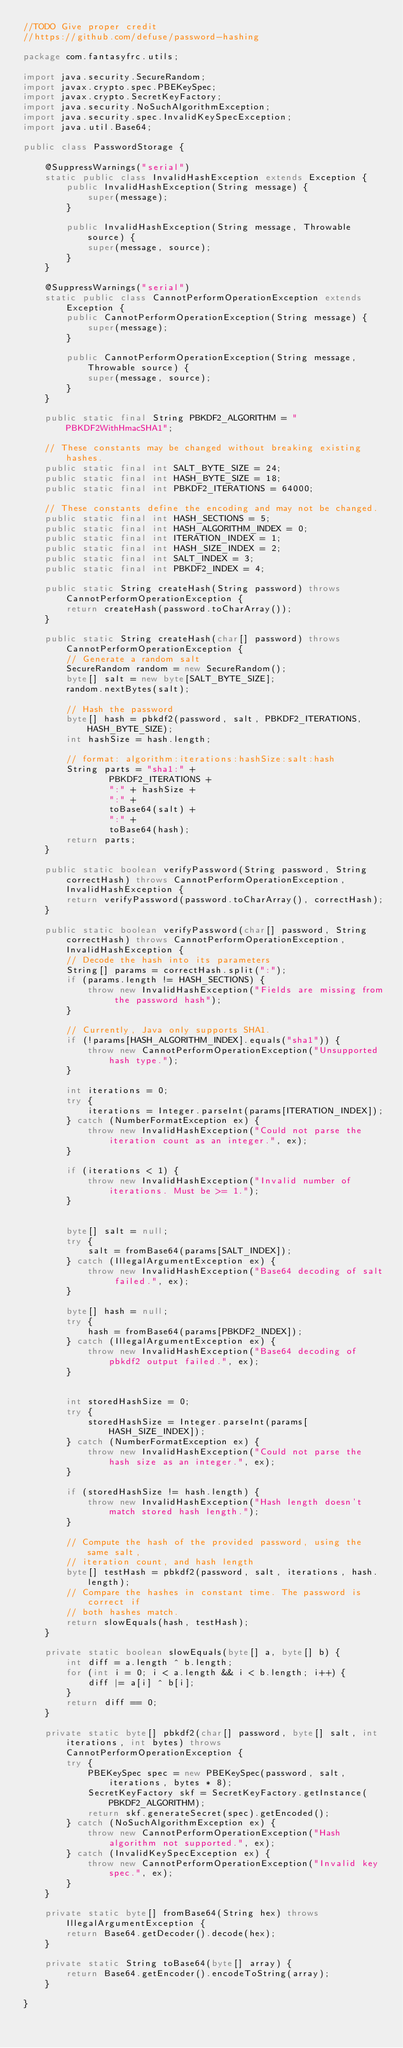<code> <loc_0><loc_0><loc_500><loc_500><_Java_>//TODO Give proper credit
//https://github.com/defuse/password-hashing

package com.fantasyfrc.utils;

import java.security.SecureRandom;
import javax.crypto.spec.PBEKeySpec;
import javax.crypto.SecretKeyFactory;
import java.security.NoSuchAlgorithmException;
import java.security.spec.InvalidKeySpecException;
import java.util.Base64;

public class PasswordStorage {

    @SuppressWarnings("serial")
    static public class InvalidHashException extends Exception {
        public InvalidHashException(String message) {
            super(message);
        }

        public InvalidHashException(String message, Throwable source) {
            super(message, source);
        }
    }

    @SuppressWarnings("serial")
    static public class CannotPerformOperationException extends Exception {
        public CannotPerformOperationException(String message) {
            super(message);
        }

        public CannotPerformOperationException(String message, Throwable source) {
            super(message, source);
        }
    }

    public static final String PBKDF2_ALGORITHM = "PBKDF2WithHmacSHA1";

    // These constants may be changed without breaking existing hashes.
    public static final int SALT_BYTE_SIZE = 24;
    public static final int HASH_BYTE_SIZE = 18;
    public static final int PBKDF2_ITERATIONS = 64000;

    // These constants define the encoding and may not be changed.
    public static final int HASH_SECTIONS = 5;
    public static final int HASH_ALGORITHM_INDEX = 0;
    public static final int ITERATION_INDEX = 1;
    public static final int HASH_SIZE_INDEX = 2;
    public static final int SALT_INDEX = 3;
    public static final int PBKDF2_INDEX = 4;

    public static String createHash(String password) throws CannotPerformOperationException {
        return createHash(password.toCharArray());
    }

    public static String createHash(char[] password) throws CannotPerformOperationException {
        // Generate a random salt
        SecureRandom random = new SecureRandom();
        byte[] salt = new byte[SALT_BYTE_SIZE];
        random.nextBytes(salt);

        // Hash the password
        byte[] hash = pbkdf2(password, salt, PBKDF2_ITERATIONS, HASH_BYTE_SIZE);
        int hashSize = hash.length;

        // format: algorithm:iterations:hashSize:salt:hash
        String parts = "sha1:" +
                PBKDF2_ITERATIONS +
                ":" + hashSize +
                ":" +
                toBase64(salt) +
                ":" +
                toBase64(hash);
        return parts;
    }

    public static boolean verifyPassword(String password, String correctHash) throws CannotPerformOperationException, InvalidHashException {
        return verifyPassword(password.toCharArray(), correctHash);
    }

    public static boolean verifyPassword(char[] password, String correctHash) throws CannotPerformOperationException, InvalidHashException {
        // Decode the hash into its parameters
        String[] params = correctHash.split(":");
        if (params.length != HASH_SECTIONS) {
            throw new InvalidHashException("Fields are missing from the password hash");
        }

        // Currently, Java only supports SHA1.
        if (!params[HASH_ALGORITHM_INDEX].equals("sha1")) {
            throw new CannotPerformOperationException("Unsupported hash type.");
        }

        int iterations = 0;
        try {
            iterations = Integer.parseInt(params[ITERATION_INDEX]);
        } catch (NumberFormatException ex) {
            throw new InvalidHashException("Could not parse the iteration count as an integer.", ex);
        }

        if (iterations < 1) {
            throw new InvalidHashException("Invalid number of iterations. Must be >= 1.");
        }


        byte[] salt = null;
        try {
            salt = fromBase64(params[SALT_INDEX]);
        } catch (IllegalArgumentException ex) {
            throw new InvalidHashException("Base64 decoding of salt failed.", ex);
        }

        byte[] hash = null;
        try {
            hash = fromBase64(params[PBKDF2_INDEX]);
        } catch (IllegalArgumentException ex) {
            throw new InvalidHashException("Base64 decoding of pbkdf2 output failed.", ex);
        }


        int storedHashSize = 0;
        try {
            storedHashSize = Integer.parseInt(params[HASH_SIZE_INDEX]);
        } catch (NumberFormatException ex) {
            throw new InvalidHashException("Could not parse the hash size as an integer.", ex);
        }

        if (storedHashSize != hash.length) {
            throw new InvalidHashException("Hash length doesn't match stored hash length.");
        }

        // Compute the hash of the provided password, using the same salt,
        // iteration count, and hash length
        byte[] testHash = pbkdf2(password, salt, iterations, hash.length);
        // Compare the hashes in constant time. The password is correct if
        // both hashes match.
        return slowEquals(hash, testHash);
    }

    private static boolean slowEquals(byte[] a, byte[] b) {
        int diff = a.length ^ b.length;
        for (int i = 0; i < a.length && i < b.length; i++) {
            diff |= a[i] ^ b[i];
        }
        return diff == 0;
    }

    private static byte[] pbkdf2(char[] password, byte[] salt, int iterations, int bytes) throws CannotPerformOperationException {
        try {
            PBEKeySpec spec = new PBEKeySpec(password, salt, iterations, bytes * 8);
            SecretKeyFactory skf = SecretKeyFactory.getInstance(PBKDF2_ALGORITHM);
            return skf.generateSecret(spec).getEncoded();
        } catch (NoSuchAlgorithmException ex) {
            throw new CannotPerformOperationException("Hash algorithm not supported.", ex);
        } catch (InvalidKeySpecException ex) {
            throw new CannotPerformOperationException("Invalid key spec.", ex);
        }
    }

    private static byte[] fromBase64(String hex) throws IllegalArgumentException {
        return Base64.getDecoder().decode(hex);
    }

    private static String toBase64(byte[] array) {
        return Base64.getEncoder().encodeToString(array);
    }

}
</code> 